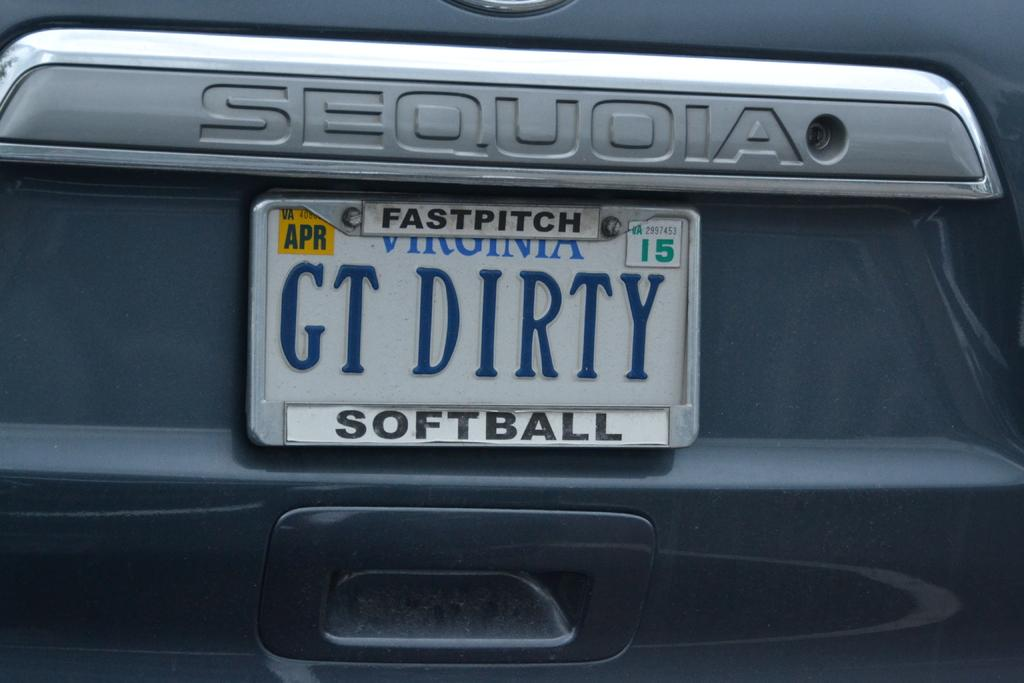<image>
Create a compact narrative representing the image presented. Gray Virginia license plate which says GT DIRTY on it. 